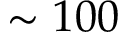<formula> <loc_0><loc_0><loc_500><loc_500>\sim 1 0 0</formula> 